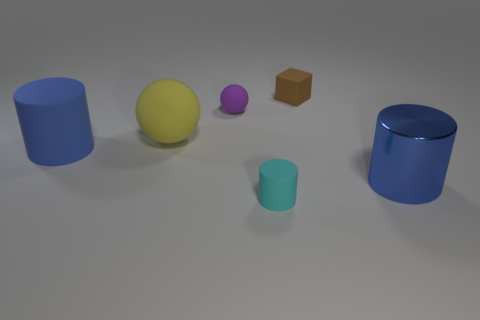What size is the rubber thing in front of the blue rubber object?
Provide a short and direct response. Small. Are there the same number of large rubber cylinders that are right of the tiny brown cube and matte cylinders?
Give a very brief answer. No. Is there a large brown thing of the same shape as the big yellow object?
Keep it short and to the point. No. What is the shape of the object that is both on the right side of the yellow sphere and to the left of the cyan matte thing?
Make the answer very short. Sphere. Are the tiny ball and the blue object right of the tiny brown rubber object made of the same material?
Offer a very short reply. No. Are there any tiny matte balls right of the shiny thing?
Ensure brevity in your answer.  No. What number of things are either rubber blocks or things that are to the right of the small cyan thing?
Provide a succinct answer. 2. The big cylinder that is behind the large blue cylinder that is to the right of the matte cube is what color?
Provide a succinct answer. Blue. How many other objects are the same material as the yellow ball?
Keep it short and to the point. 4. How many metallic objects are either large yellow spheres or brown things?
Ensure brevity in your answer.  0. 